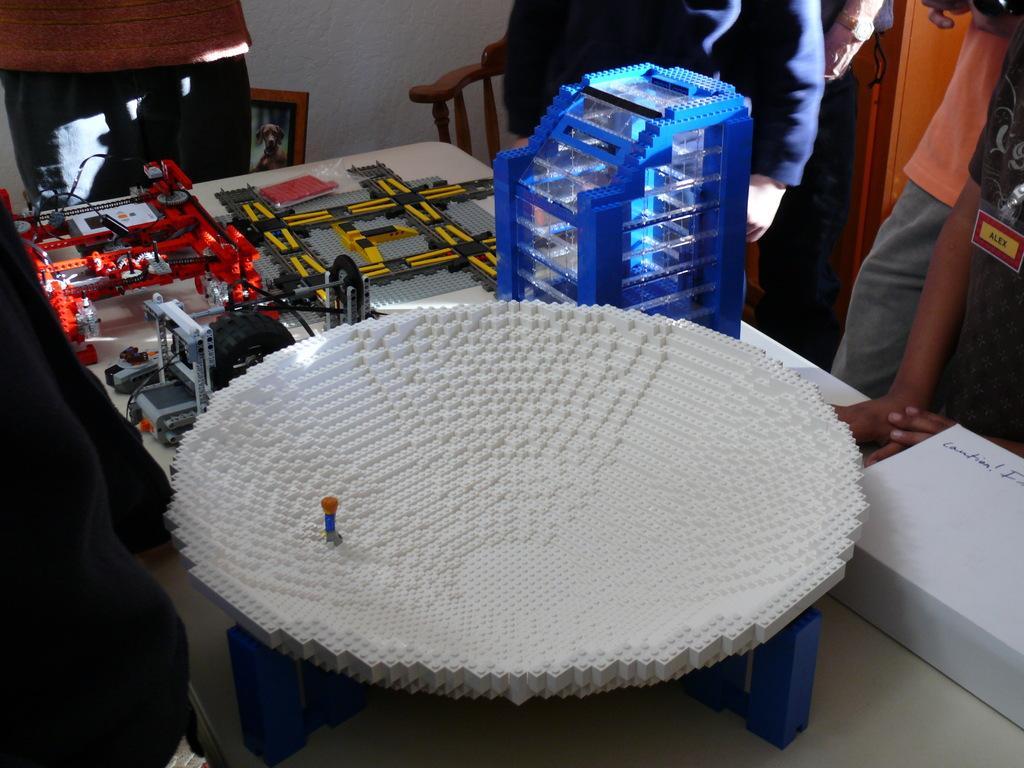In one or two sentences, can you explain what this image depicts? In the center of the image there are crafts which are made with lego bricks. There is a table. In the background there are people standing around the table. There is a chair. 